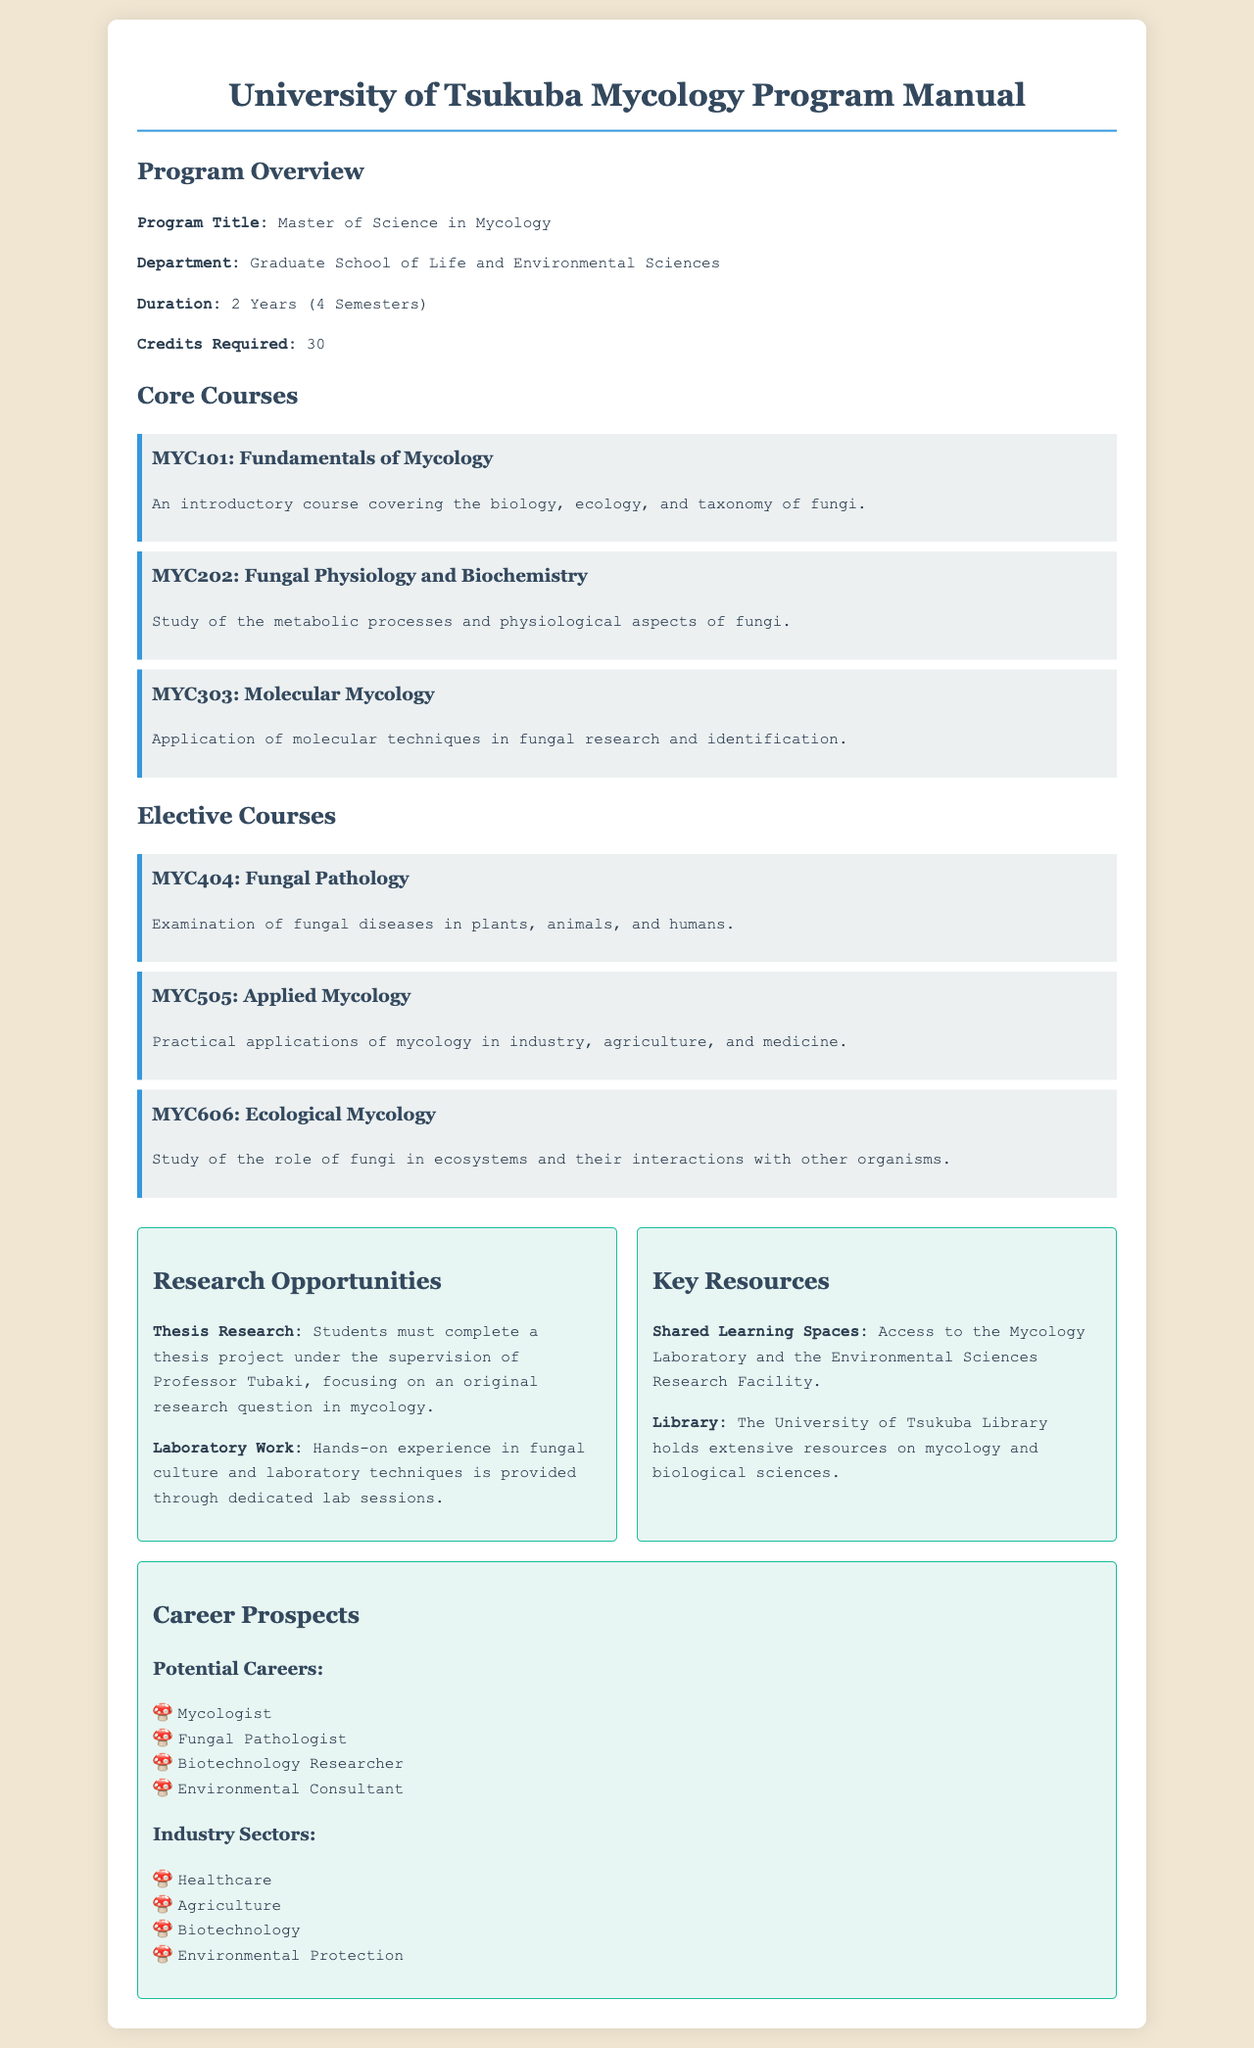What is the program title? The program title is provided in the overview section, clearly stating the name of the program.
Answer: Master of Science in Mycology How many credits are required for the program? The document specifies the total number of credits necessary for completion of the program.
Answer: 30 Who supervises the thesis research? The manual indicates the faculty member responsible for supervising thesis projects.
Answer: Professor Tubaki Which course covers the biology, ecology, and taxonomy of fungi? The course description in the core courses section clearly identifies the subject matter of the offered courses.
Answer: MYC101: Fundamentals of Mycology What is the duration of the Mycology program? The duration is explicitly mentioned in the overview of the program.
Answer: 2 Years (4 Semesters) What hands-on experience is offered in the program? The manual describes the type of practical experience students will gain through the coursework.
Answer: Laboratory Work Name one potential career for graduates of the Mycology program. The program outlines possible career paths for its graduates in the career prospects section.
Answer: Mycologist What type of learning spaces are available to students? The key resources section details the shared facilities accessible to students in the program.
Answer: Mycology Laboratory Which elective course examines fungal diseases? The elective courses section lists various courses with their focus areas.
Answer: MYC404: Fungal Pathology 